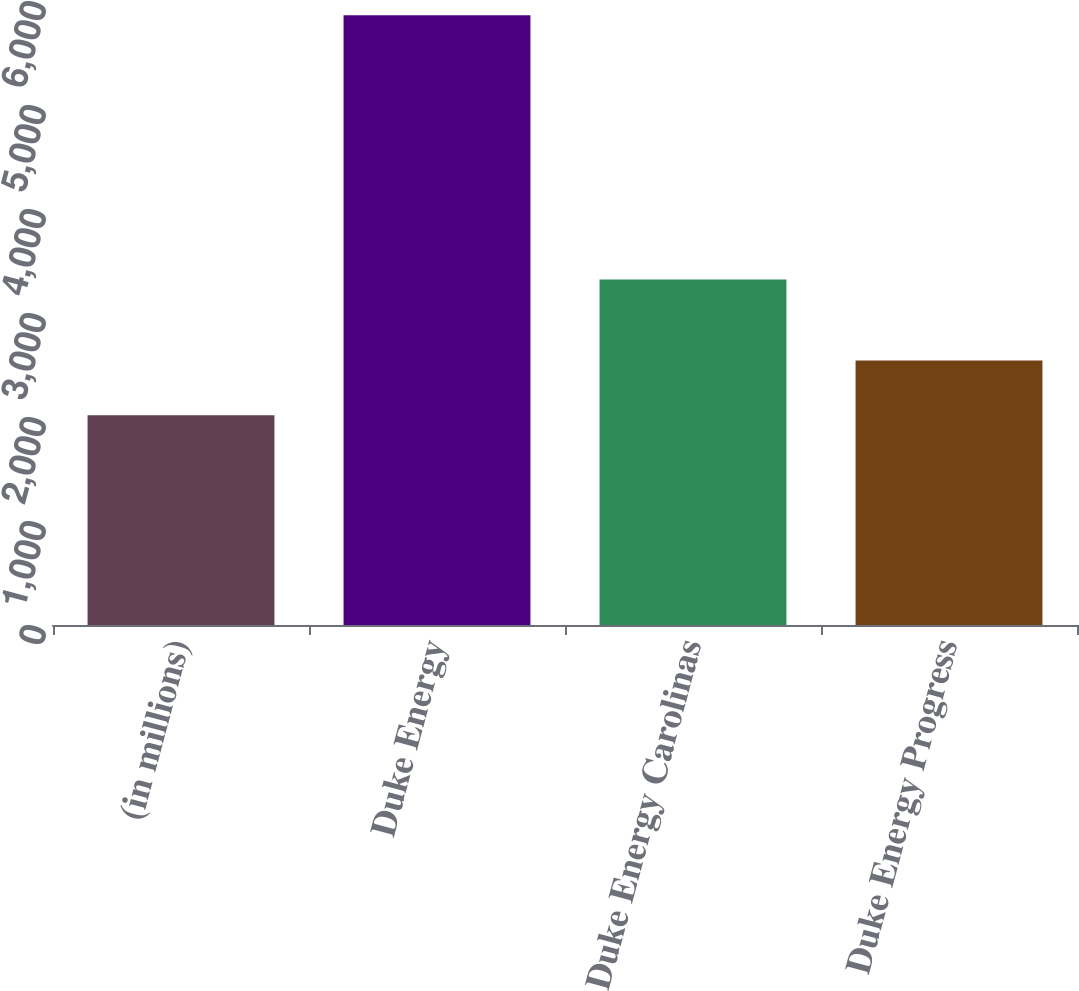<chart> <loc_0><loc_0><loc_500><loc_500><bar_chart><fcel>(in millions)<fcel>Duke Energy<fcel>Duke Energy Carolinas<fcel>Duke Energy Progress<nl><fcel>2017<fcel>5864<fcel>3321<fcel>2543<nl></chart> 